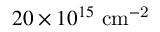<formula> <loc_0><loc_0><loc_500><loc_500>2 0 \times 1 0 ^ { 1 5 } \ c m ^ { - 2 }</formula> 